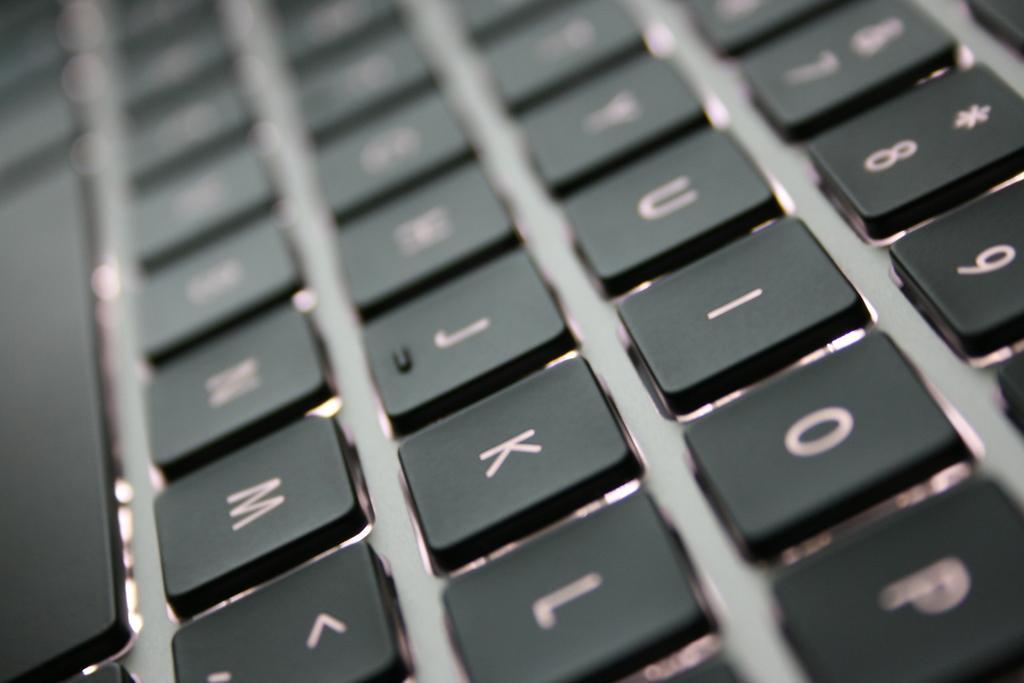Could you give a brief overview of what you see in this image? Here I can see the black color buttons of a keyboard. On each button I can see the letters and numbers. 